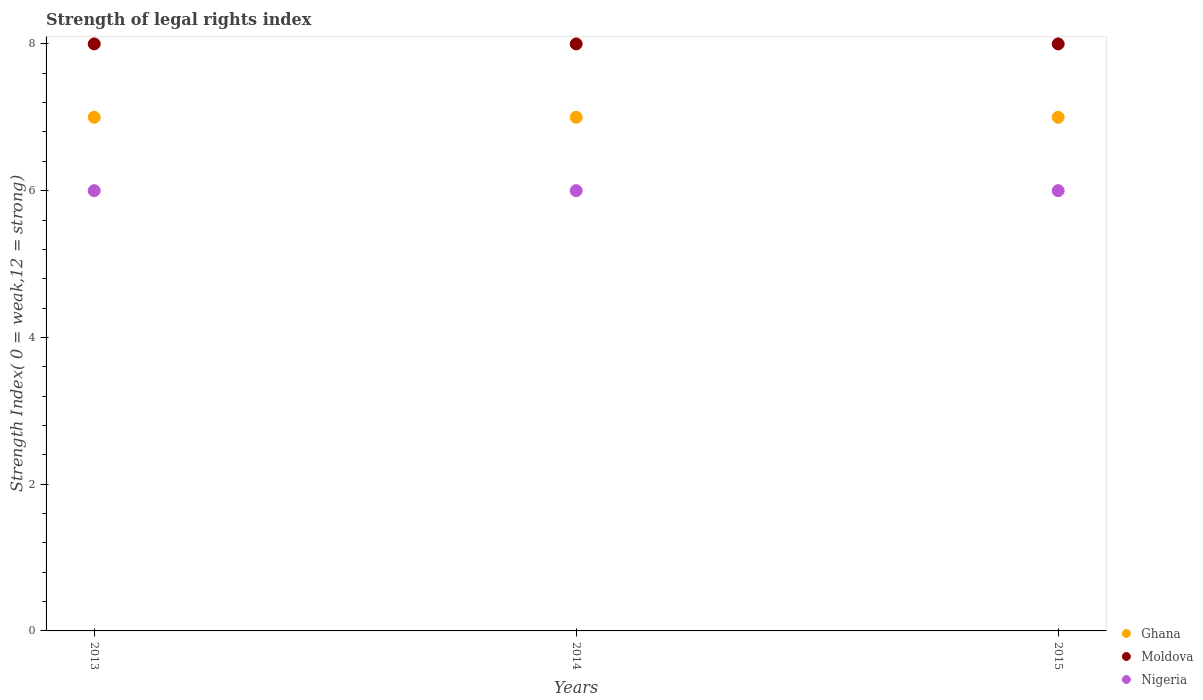How many different coloured dotlines are there?
Your answer should be compact. 3. Is the number of dotlines equal to the number of legend labels?
Offer a terse response. Yes. What is the strength index in Moldova in 2015?
Provide a succinct answer. 8. Across all years, what is the minimum strength index in Ghana?
Your answer should be very brief. 7. In which year was the strength index in Moldova maximum?
Ensure brevity in your answer.  2013. What is the total strength index in Moldova in the graph?
Offer a terse response. 24. What is the difference between the strength index in Nigeria in 2014 and that in 2015?
Give a very brief answer. 0. What is the difference between the strength index in Ghana in 2015 and the strength index in Nigeria in 2014?
Your response must be concise. 1. In the year 2013, what is the difference between the strength index in Ghana and strength index in Moldova?
Make the answer very short. -1. Is the strength index in Moldova in 2014 less than that in 2015?
Keep it short and to the point. No. Is the difference between the strength index in Ghana in 2014 and 2015 greater than the difference between the strength index in Moldova in 2014 and 2015?
Provide a succinct answer. No. What is the difference between the highest and the second highest strength index in Ghana?
Your response must be concise. 0. In how many years, is the strength index in Ghana greater than the average strength index in Ghana taken over all years?
Offer a very short reply. 0. Is it the case that in every year, the sum of the strength index in Nigeria and strength index in Moldova  is greater than the strength index in Ghana?
Your answer should be compact. Yes. Does the strength index in Ghana monotonically increase over the years?
Your answer should be compact. No. How many dotlines are there?
Ensure brevity in your answer.  3. How many years are there in the graph?
Offer a terse response. 3. What is the difference between two consecutive major ticks on the Y-axis?
Your response must be concise. 2. Does the graph contain grids?
Offer a very short reply. No. Where does the legend appear in the graph?
Provide a short and direct response. Bottom right. How are the legend labels stacked?
Offer a terse response. Vertical. What is the title of the graph?
Offer a terse response. Strength of legal rights index. Does "West Bank and Gaza" appear as one of the legend labels in the graph?
Your response must be concise. No. What is the label or title of the X-axis?
Provide a succinct answer. Years. What is the label or title of the Y-axis?
Provide a short and direct response. Strength Index( 0 = weak,12 = strong). What is the Strength Index( 0 = weak,12 = strong) of Ghana in 2013?
Provide a succinct answer. 7. What is the Strength Index( 0 = weak,12 = strong) of Ghana in 2014?
Offer a terse response. 7. Across all years, what is the maximum Strength Index( 0 = weak,12 = strong) in Nigeria?
Your response must be concise. 6. Across all years, what is the minimum Strength Index( 0 = weak,12 = strong) of Nigeria?
Your response must be concise. 6. What is the difference between the Strength Index( 0 = weak,12 = strong) of Ghana in 2013 and that in 2014?
Offer a terse response. 0. What is the difference between the Strength Index( 0 = weak,12 = strong) of Ghana in 2013 and that in 2015?
Provide a short and direct response. 0. What is the difference between the Strength Index( 0 = weak,12 = strong) of Nigeria in 2013 and that in 2015?
Give a very brief answer. 0. What is the difference between the Strength Index( 0 = weak,12 = strong) of Moldova in 2014 and that in 2015?
Your answer should be compact. 0. What is the difference between the Strength Index( 0 = weak,12 = strong) of Ghana in 2013 and the Strength Index( 0 = weak,12 = strong) of Moldova in 2014?
Keep it short and to the point. -1. What is the difference between the Strength Index( 0 = weak,12 = strong) in Moldova in 2013 and the Strength Index( 0 = weak,12 = strong) in Nigeria in 2014?
Give a very brief answer. 2. What is the difference between the Strength Index( 0 = weak,12 = strong) of Moldova in 2013 and the Strength Index( 0 = weak,12 = strong) of Nigeria in 2015?
Provide a succinct answer. 2. What is the difference between the Strength Index( 0 = weak,12 = strong) of Ghana in 2014 and the Strength Index( 0 = weak,12 = strong) of Moldova in 2015?
Offer a very short reply. -1. What is the difference between the Strength Index( 0 = weak,12 = strong) in Ghana in 2014 and the Strength Index( 0 = weak,12 = strong) in Nigeria in 2015?
Offer a very short reply. 1. What is the average Strength Index( 0 = weak,12 = strong) in Ghana per year?
Give a very brief answer. 7. What is the average Strength Index( 0 = weak,12 = strong) of Nigeria per year?
Your answer should be compact. 6. In the year 2013, what is the difference between the Strength Index( 0 = weak,12 = strong) in Moldova and Strength Index( 0 = weak,12 = strong) in Nigeria?
Provide a short and direct response. 2. In the year 2014, what is the difference between the Strength Index( 0 = weak,12 = strong) in Ghana and Strength Index( 0 = weak,12 = strong) in Moldova?
Give a very brief answer. -1. In the year 2014, what is the difference between the Strength Index( 0 = weak,12 = strong) of Ghana and Strength Index( 0 = weak,12 = strong) of Nigeria?
Your answer should be compact. 1. What is the ratio of the Strength Index( 0 = weak,12 = strong) in Ghana in 2013 to that in 2014?
Your answer should be very brief. 1. What is the ratio of the Strength Index( 0 = weak,12 = strong) of Moldova in 2013 to that in 2014?
Provide a short and direct response. 1. What is the ratio of the Strength Index( 0 = weak,12 = strong) in Nigeria in 2013 to that in 2015?
Your response must be concise. 1. What is the ratio of the Strength Index( 0 = weak,12 = strong) in Ghana in 2014 to that in 2015?
Offer a terse response. 1. What is the ratio of the Strength Index( 0 = weak,12 = strong) of Moldova in 2014 to that in 2015?
Offer a terse response. 1. What is the difference between the highest and the second highest Strength Index( 0 = weak,12 = strong) of Moldova?
Provide a succinct answer. 0. What is the difference between the highest and the second highest Strength Index( 0 = weak,12 = strong) of Nigeria?
Make the answer very short. 0. What is the difference between the highest and the lowest Strength Index( 0 = weak,12 = strong) of Ghana?
Your answer should be very brief. 0. 